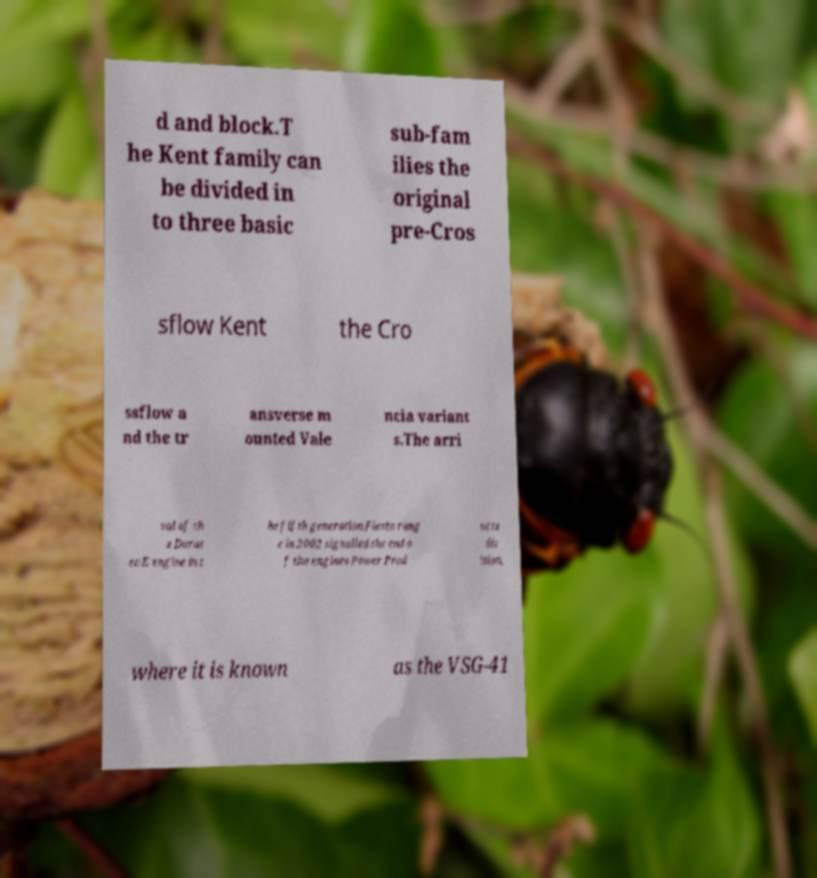Could you assist in decoding the text presented in this image and type it out clearly? d and block.T he Kent family can be divided in to three basic sub-fam ilies the original pre-Cros sflow Kent the Cro ssflow a nd the tr ansverse m ounted Vale ncia variant s.The arri val of th e Durat ec-E engine in t he fifth generation Fiesta rang e in 2002 signalled the end o f the engines Power Prod ucts div ision, where it is known as the VSG-41 